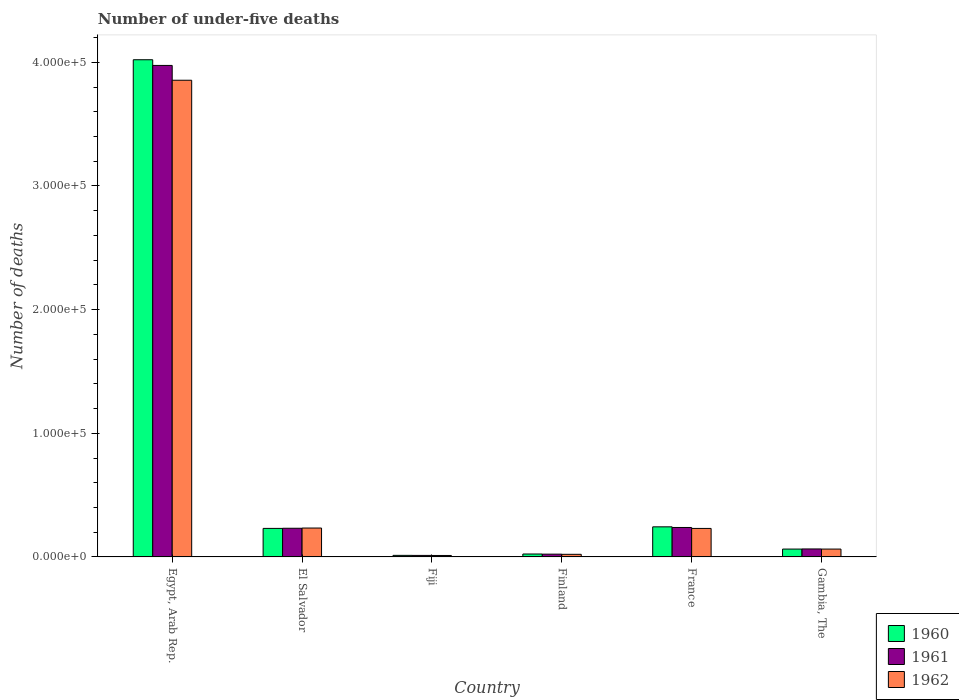How many different coloured bars are there?
Provide a short and direct response. 3. How many groups of bars are there?
Keep it short and to the point. 6. Are the number of bars per tick equal to the number of legend labels?
Your answer should be very brief. Yes. Are the number of bars on each tick of the X-axis equal?
Offer a very short reply. Yes. How many bars are there on the 4th tick from the left?
Give a very brief answer. 3. What is the label of the 2nd group of bars from the left?
Keep it short and to the point. El Salvador. What is the number of under-five deaths in 1961 in Gambia, The?
Ensure brevity in your answer.  6452. Across all countries, what is the maximum number of under-five deaths in 1962?
Your response must be concise. 3.86e+05. Across all countries, what is the minimum number of under-five deaths in 1962?
Ensure brevity in your answer.  1176. In which country was the number of under-five deaths in 1961 maximum?
Give a very brief answer. Egypt, Arab Rep. In which country was the number of under-five deaths in 1961 minimum?
Provide a short and direct response. Fiji. What is the total number of under-five deaths in 1961 in the graph?
Your answer should be very brief. 4.54e+05. What is the difference between the number of under-five deaths in 1961 in Egypt, Arab Rep. and that in El Salvador?
Make the answer very short. 3.74e+05. What is the difference between the number of under-five deaths in 1960 in Gambia, The and the number of under-five deaths in 1961 in France?
Ensure brevity in your answer.  -1.75e+04. What is the average number of under-five deaths in 1961 per country?
Ensure brevity in your answer.  7.57e+04. What is the difference between the number of under-five deaths of/in 1962 and number of under-five deaths of/in 1960 in Finland?
Provide a succinct answer. -257. In how many countries, is the number of under-five deaths in 1962 greater than 140000?
Give a very brief answer. 1. What is the ratio of the number of under-five deaths in 1960 in Egypt, Arab Rep. to that in Fiji?
Your answer should be very brief. 318.38. What is the difference between the highest and the second highest number of under-five deaths in 1961?
Make the answer very short. 3.74e+05. What is the difference between the highest and the lowest number of under-five deaths in 1961?
Offer a terse response. 3.96e+05. In how many countries, is the number of under-five deaths in 1960 greater than the average number of under-five deaths in 1960 taken over all countries?
Keep it short and to the point. 1. Is the sum of the number of under-five deaths in 1962 in Egypt, Arab Rep. and France greater than the maximum number of under-five deaths in 1960 across all countries?
Provide a succinct answer. Yes. What does the 2nd bar from the left in Egypt, Arab Rep. represents?
Your answer should be compact. 1961. How many bars are there?
Ensure brevity in your answer.  18. Are the values on the major ticks of Y-axis written in scientific E-notation?
Make the answer very short. Yes. What is the title of the graph?
Ensure brevity in your answer.  Number of under-five deaths. Does "1984" appear as one of the legend labels in the graph?
Keep it short and to the point. No. What is the label or title of the Y-axis?
Keep it short and to the point. Number of deaths. What is the Number of deaths of 1960 in Egypt, Arab Rep.?
Ensure brevity in your answer.  4.02e+05. What is the Number of deaths in 1961 in Egypt, Arab Rep.?
Offer a terse response. 3.98e+05. What is the Number of deaths of 1962 in Egypt, Arab Rep.?
Your response must be concise. 3.86e+05. What is the Number of deaths in 1960 in El Salvador?
Make the answer very short. 2.31e+04. What is the Number of deaths in 1961 in El Salvador?
Keep it short and to the point. 2.32e+04. What is the Number of deaths of 1962 in El Salvador?
Offer a very short reply. 2.34e+04. What is the Number of deaths of 1960 in Fiji?
Offer a terse response. 1263. What is the Number of deaths of 1961 in Fiji?
Your answer should be very brief. 1222. What is the Number of deaths of 1962 in Fiji?
Provide a short and direct response. 1176. What is the Number of deaths of 1960 in Finland?
Offer a very short reply. 2363. What is the Number of deaths in 1961 in Finland?
Ensure brevity in your answer.  2251. What is the Number of deaths in 1962 in Finland?
Your response must be concise. 2106. What is the Number of deaths of 1960 in France?
Offer a very short reply. 2.43e+04. What is the Number of deaths of 1961 in France?
Your answer should be very brief. 2.38e+04. What is the Number of deaths in 1962 in France?
Offer a very short reply. 2.30e+04. What is the Number of deaths in 1960 in Gambia, The?
Provide a succinct answer. 6353. What is the Number of deaths of 1961 in Gambia, The?
Provide a short and direct response. 6452. What is the Number of deaths in 1962 in Gambia, The?
Ensure brevity in your answer.  6361. Across all countries, what is the maximum Number of deaths of 1960?
Make the answer very short. 4.02e+05. Across all countries, what is the maximum Number of deaths in 1961?
Keep it short and to the point. 3.98e+05. Across all countries, what is the maximum Number of deaths in 1962?
Keep it short and to the point. 3.86e+05. Across all countries, what is the minimum Number of deaths of 1960?
Offer a very short reply. 1263. Across all countries, what is the minimum Number of deaths of 1961?
Make the answer very short. 1222. Across all countries, what is the minimum Number of deaths in 1962?
Keep it short and to the point. 1176. What is the total Number of deaths in 1960 in the graph?
Make the answer very short. 4.60e+05. What is the total Number of deaths in 1961 in the graph?
Ensure brevity in your answer.  4.54e+05. What is the total Number of deaths in 1962 in the graph?
Provide a short and direct response. 4.42e+05. What is the difference between the Number of deaths of 1960 in Egypt, Arab Rep. and that in El Salvador?
Offer a very short reply. 3.79e+05. What is the difference between the Number of deaths of 1961 in Egypt, Arab Rep. and that in El Salvador?
Offer a very short reply. 3.74e+05. What is the difference between the Number of deaths in 1962 in Egypt, Arab Rep. and that in El Salvador?
Keep it short and to the point. 3.62e+05. What is the difference between the Number of deaths in 1960 in Egypt, Arab Rep. and that in Fiji?
Provide a succinct answer. 4.01e+05. What is the difference between the Number of deaths in 1961 in Egypt, Arab Rep. and that in Fiji?
Provide a short and direct response. 3.96e+05. What is the difference between the Number of deaths in 1962 in Egypt, Arab Rep. and that in Fiji?
Your answer should be compact. 3.84e+05. What is the difference between the Number of deaths in 1960 in Egypt, Arab Rep. and that in Finland?
Offer a very short reply. 4.00e+05. What is the difference between the Number of deaths in 1961 in Egypt, Arab Rep. and that in Finland?
Offer a very short reply. 3.95e+05. What is the difference between the Number of deaths of 1962 in Egypt, Arab Rep. and that in Finland?
Your response must be concise. 3.83e+05. What is the difference between the Number of deaths in 1960 in Egypt, Arab Rep. and that in France?
Offer a very short reply. 3.78e+05. What is the difference between the Number of deaths in 1961 in Egypt, Arab Rep. and that in France?
Keep it short and to the point. 3.74e+05. What is the difference between the Number of deaths of 1962 in Egypt, Arab Rep. and that in France?
Provide a succinct answer. 3.62e+05. What is the difference between the Number of deaths in 1960 in Egypt, Arab Rep. and that in Gambia, The?
Keep it short and to the point. 3.96e+05. What is the difference between the Number of deaths of 1961 in Egypt, Arab Rep. and that in Gambia, The?
Your answer should be very brief. 3.91e+05. What is the difference between the Number of deaths in 1962 in Egypt, Arab Rep. and that in Gambia, The?
Provide a short and direct response. 3.79e+05. What is the difference between the Number of deaths in 1960 in El Salvador and that in Fiji?
Ensure brevity in your answer.  2.18e+04. What is the difference between the Number of deaths in 1961 in El Salvador and that in Fiji?
Your response must be concise. 2.20e+04. What is the difference between the Number of deaths of 1962 in El Salvador and that in Fiji?
Give a very brief answer. 2.22e+04. What is the difference between the Number of deaths of 1960 in El Salvador and that in Finland?
Your response must be concise. 2.07e+04. What is the difference between the Number of deaths of 1961 in El Salvador and that in Finland?
Keep it short and to the point. 2.09e+04. What is the difference between the Number of deaths in 1962 in El Salvador and that in Finland?
Provide a succinct answer. 2.13e+04. What is the difference between the Number of deaths in 1960 in El Salvador and that in France?
Provide a short and direct response. -1262. What is the difference between the Number of deaths of 1961 in El Salvador and that in France?
Give a very brief answer. -627. What is the difference between the Number of deaths of 1962 in El Salvador and that in France?
Give a very brief answer. 323. What is the difference between the Number of deaths in 1960 in El Salvador and that in Gambia, The?
Provide a short and direct response. 1.67e+04. What is the difference between the Number of deaths in 1961 in El Salvador and that in Gambia, The?
Offer a very short reply. 1.67e+04. What is the difference between the Number of deaths in 1962 in El Salvador and that in Gambia, The?
Your answer should be compact. 1.70e+04. What is the difference between the Number of deaths of 1960 in Fiji and that in Finland?
Make the answer very short. -1100. What is the difference between the Number of deaths in 1961 in Fiji and that in Finland?
Offer a very short reply. -1029. What is the difference between the Number of deaths of 1962 in Fiji and that in Finland?
Give a very brief answer. -930. What is the difference between the Number of deaths in 1960 in Fiji and that in France?
Offer a terse response. -2.31e+04. What is the difference between the Number of deaths in 1961 in Fiji and that in France?
Give a very brief answer. -2.26e+04. What is the difference between the Number of deaths in 1962 in Fiji and that in France?
Ensure brevity in your answer.  -2.19e+04. What is the difference between the Number of deaths in 1960 in Fiji and that in Gambia, The?
Offer a very short reply. -5090. What is the difference between the Number of deaths in 1961 in Fiji and that in Gambia, The?
Offer a terse response. -5230. What is the difference between the Number of deaths of 1962 in Fiji and that in Gambia, The?
Offer a very short reply. -5185. What is the difference between the Number of deaths of 1960 in Finland and that in France?
Your response must be concise. -2.20e+04. What is the difference between the Number of deaths of 1961 in Finland and that in France?
Provide a succinct answer. -2.16e+04. What is the difference between the Number of deaths in 1962 in Finland and that in France?
Your response must be concise. -2.09e+04. What is the difference between the Number of deaths in 1960 in Finland and that in Gambia, The?
Offer a terse response. -3990. What is the difference between the Number of deaths of 1961 in Finland and that in Gambia, The?
Offer a terse response. -4201. What is the difference between the Number of deaths in 1962 in Finland and that in Gambia, The?
Offer a terse response. -4255. What is the difference between the Number of deaths in 1960 in France and that in Gambia, The?
Your answer should be compact. 1.80e+04. What is the difference between the Number of deaths of 1961 in France and that in Gambia, The?
Provide a short and direct response. 1.74e+04. What is the difference between the Number of deaths of 1962 in France and that in Gambia, The?
Give a very brief answer. 1.67e+04. What is the difference between the Number of deaths in 1960 in Egypt, Arab Rep. and the Number of deaths in 1961 in El Salvador?
Give a very brief answer. 3.79e+05. What is the difference between the Number of deaths of 1960 in Egypt, Arab Rep. and the Number of deaths of 1962 in El Salvador?
Your answer should be compact. 3.79e+05. What is the difference between the Number of deaths in 1961 in Egypt, Arab Rep. and the Number of deaths in 1962 in El Salvador?
Provide a short and direct response. 3.74e+05. What is the difference between the Number of deaths of 1960 in Egypt, Arab Rep. and the Number of deaths of 1961 in Fiji?
Your answer should be very brief. 4.01e+05. What is the difference between the Number of deaths of 1960 in Egypt, Arab Rep. and the Number of deaths of 1962 in Fiji?
Your response must be concise. 4.01e+05. What is the difference between the Number of deaths in 1961 in Egypt, Arab Rep. and the Number of deaths in 1962 in Fiji?
Keep it short and to the point. 3.96e+05. What is the difference between the Number of deaths in 1960 in Egypt, Arab Rep. and the Number of deaths in 1961 in Finland?
Offer a terse response. 4.00e+05. What is the difference between the Number of deaths of 1960 in Egypt, Arab Rep. and the Number of deaths of 1962 in Finland?
Provide a succinct answer. 4.00e+05. What is the difference between the Number of deaths of 1961 in Egypt, Arab Rep. and the Number of deaths of 1962 in Finland?
Provide a succinct answer. 3.95e+05. What is the difference between the Number of deaths in 1960 in Egypt, Arab Rep. and the Number of deaths in 1961 in France?
Give a very brief answer. 3.78e+05. What is the difference between the Number of deaths of 1960 in Egypt, Arab Rep. and the Number of deaths of 1962 in France?
Ensure brevity in your answer.  3.79e+05. What is the difference between the Number of deaths in 1961 in Egypt, Arab Rep. and the Number of deaths in 1962 in France?
Your answer should be compact. 3.74e+05. What is the difference between the Number of deaths in 1960 in Egypt, Arab Rep. and the Number of deaths in 1961 in Gambia, The?
Provide a succinct answer. 3.96e+05. What is the difference between the Number of deaths in 1960 in Egypt, Arab Rep. and the Number of deaths in 1962 in Gambia, The?
Your answer should be very brief. 3.96e+05. What is the difference between the Number of deaths of 1961 in Egypt, Arab Rep. and the Number of deaths of 1962 in Gambia, The?
Provide a short and direct response. 3.91e+05. What is the difference between the Number of deaths in 1960 in El Salvador and the Number of deaths in 1961 in Fiji?
Provide a short and direct response. 2.19e+04. What is the difference between the Number of deaths in 1960 in El Salvador and the Number of deaths in 1962 in Fiji?
Give a very brief answer. 2.19e+04. What is the difference between the Number of deaths of 1961 in El Salvador and the Number of deaths of 1962 in Fiji?
Offer a very short reply. 2.20e+04. What is the difference between the Number of deaths in 1960 in El Salvador and the Number of deaths in 1961 in Finland?
Provide a succinct answer. 2.08e+04. What is the difference between the Number of deaths of 1960 in El Salvador and the Number of deaths of 1962 in Finland?
Make the answer very short. 2.10e+04. What is the difference between the Number of deaths in 1961 in El Salvador and the Number of deaths in 1962 in Finland?
Your answer should be compact. 2.11e+04. What is the difference between the Number of deaths of 1960 in El Salvador and the Number of deaths of 1961 in France?
Provide a succinct answer. -745. What is the difference between the Number of deaths in 1961 in El Salvador and the Number of deaths in 1962 in France?
Make the answer very short. 148. What is the difference between the Number of deaths of 1960 in El Salvador and the Number of deaths of 1961 in Gambia, The?
Offer a very short reply. 1.66e+04. What is the difference between the Number of deaths in 1960 in El Salvador and the Number of deaths in 1962 in Gambia, The?
Ensure brevity in your answer.  1.67e+04. What is the difference between the Number of deaths in 1961 in El Salvador and the Number of deaths in 1962 in Gambia, The?
Provide a succinct answer. 1.68e+04. What is the difference between the Number of deaths of 1960 in Fiji and the Number of deaths of 1961 in Finland?
Make the answer very short. -988. What is the difference between the Number of deaths in 1960 in Fiji and the Number of deaths in 1962 in Finland?
Provide a succinct answer. -843. What is the difference between the Number of deaths of 1961 in Fiji and the Number of deaths of 1962 in Finland?
Ensure brevity in your answer.  -884. What is the difference between the Number of deaths in 1960 in Fiji and the Number of deaths in 1961 in France?
Give a very brief answer. -2.26e+04. What is the difference between the Number of deaths in 1960 in Fiji and the Number of deaths in 1962 in France?
Provide a short and direct response. -2.18e+04. What is the difference between the Number of deaths of 1961 in Fiji and the Number of deaths of 1962 in France?
Give a very brief answer. -2.18e+04. What is the difference between the Number of deaths of 1960 in Fiji and the Number of deaths of 1961 in Gambia, The?
Your answer should be compact. -5189. What is the difference between the Number of deaths of 1960 in Fiji and the Number of deaths of 1962 in Gambia, The?
Your answer should be very brief. -5098. What is the difference between the Number of deaths of 1961 in Fiji and the Number of deaths of 1962 in Gambia, The?
Provide a short and direct response. -5139. What is the difference between the Number of deaths in 1960 in Finland and the Number of deaths in 1961 in France?
Your response must be concise. -2.15e+04. What is the difference between the Number of deaths of 1960 in Finland and the Number of deaths of 1962 in France?
Offer a very short reply. -2.07e+04. What is the difference between the Number of deaths of 1961 in Finland and the Number of deaths of 1962 in France?
Your response must be concise. -2.08e+04. What is the difference between the Number of deaths in 1960 in Finland and the Number of deaths in 1961 in Gambia, The?
Offer a terse response. -4089. What is the difference between the Number of deaths in 1960 in Finland and the Number of deaths in 1962 in Gambia, The?
Offer a very short reply. -3998. What is the difference between the Number of deaths of 1961 in Finland and the Number of deaths of 1962 in Gambia, The?
Offer a very short reply. -4110. What is the difference between the Number of deaths in 1960 in France and the Number of deaths in 1961 in Gambia, The?
Your answer should be compact. 1.79e+04. What is the difference between the Number of deaths in 1960 in France and the Number of deaths in 1962 in Gambia, The?
Provide a succinct answer. 1.80e+04. What is the difference between the Number of deaths in 1961 in France and the Number of deaths in 1962 in Gambia, The?
Your response must be concise. 1.75e+04. What is the average Number of deaths of 1960 per country?
Keep it short and to the point. 7.66e+04. What is the average Number of deaths of 1961 per country?
Provide a short and direct response. 7.57e+04. What is the average Number of deaths in 1962 per country?
Your response must be concise. 7.36e+04. What is the difference between the Number of deaths of 1960 and Number of deaths of 1961 in Egypt, Arab Rep.?
Your answer should be compact. 4607. What is the difference between the Number of deaths in 1960 and Number of deaths in 1962 in Egypt, Arab Rep.?
Offer a very short reply. 1.66e+04. What is the difference between the Number of deaths in 1961 and Number of deaths in 1962 in Egypt, Arab Rep.?
Give a very brief answer. 1.20e+04. What is the difference between the Number of deaths of 1960 and Number of deaths of 1961 in El Salvador?
Keep it short and to the point. -118. What is the difference between the Number of deaths of 1960 and Number of deaths of 1962 in El Salvador?
Keep it short and to the point. -293. What is the difference between the Number of deaths in 1961 and Number of deaths in 1962 in El Salvador?
Your response must be concise. -175. What is the difference between the Number of deaths of 1960 and Number of deaths of 1962 in Fiji?
Offer a very short reply. 87. What is the difference between the Number of deaths of 1961 and Number of deaths of 1962 in Fiji?
Offer a very short reply. 46. What is the difference between the Number of deaths in 1960 and Number of deaths in 1961 in Finland?
Offer a terse response. 112. What is the difference between the Number of deaths in 1960 and Number of deaths in 1962 in Finland?
Make the answer very short. 257. What is the difference between the Number of deaths in 1961 and Number of deaths in 1962 in Finland?
Provide a succinct answer. 145. What is the difference between the Number of deaths of 1960 and Number of deaths of 1961 in France?
Offer a very short reply. 517. What is the difference between the Number of deaths of 1960 and Number of deaths of 1962 in France?
Offer a very short reply. 1292. What is the difference between the Number of deaths in 1961 and Number of deaths in 1962 in France?
Your answer should be compact. 775. What is the difference between the Number of deaths in 1960 and Number of deaths in 1961 in Gambia, The?
Provide a short and direct response. -99. What is the difference between the Number of deaths of 1961 and Number of deaths of 1962 in Gambia, The?
Provide a short and direct response. 91. What is the ratio of the Number of deaths in 1960 in Egypt, Arab Rep. to that in El Salvador?
Your answer should be very brief. 17.43. What is the ratio of the Number of deaths in 1961 in Egypt, Arab Rep. to that in El Salvador?
Offer a very short reply. 17.14. What is the ratio of the Number of deaths of 1962 in Egypt, Arab Rep. to that in El Salvador?
Your response must be concise. 16.5. What is the ratio of the Number of deaths of 1960 in Egypt, Arab Rep. to that in Fiji?
Provide a short and direct response. 318.38. What is the ratio of the Number of deaths of 1961 in Egypt, Arab Rep. to that in Fiji?
Your answer should be compact. 325.29. What is the ratio of the Number of deaths of 1962 in Egypt, Arab Rep. to that in Fiji?
Offer a very short reply. 327.83. What is the ratio of the Number of deaths of 1960 in Egypt, Arab Rep. to that in Finland?
Your response must be concise. 170.17. What is the ratio of the Number of deaths in 1961 in Egypt, Arab Rep. to that in Finland?
Keep it short and to the point. 176.59. What is the ratio of the Number of deaths of 1962 in Egypt, Arab Rep. to that in Finland?
Ensure brevity in your answer.  183.06. What is the ratio of the Number of deaths of 1960 in Egypt, Arab Rep. to that in France?
Your response must be concise. 16.52. What is the ratio of the Number of deaths of 1961 in Egypt, Arab Rep. to that in France?
Offer a terse response. 16.69. What is the ratio of the Number of deaths of 1962 in Egypt, Arab Rep. to that in France?
Your response must be concise. 16.73. What is the ratio of the Number of deaths in 1960 in Egypt, Arab Rep. to that in Gambia, The?
Make the answer very short. 63.3. What is the ratio of the Number of deaths in 1961 in Egypt, Arab Rep. to that in Gambia, The?
Provide a succinct answer. 61.61. What is the ratio of the Number of deaths in 1962 in Egypt, Arab Rep. to that in Gambia, The?
Offer a terse response. 60.61. What is the ratio of the Number of deaths of 1960 in El Salvador to that in Fiji?
Your answer should be very brief. 18.27. What is the ratio of the Number of deaths of 1961 in El Salvador to that in Fiji?
Offer a very short reply. 18.98. What is the ratio of the Number of deaths in 1962 in El Salvador to that in Fiji?
Your answer should be compact. 19.87. What is the ratio of the Number of deaths of 1960 in El Salvador to that in Finland?
Ensure brevity in your answer.  9.76. What is the ratio of the Number of deaths in 1961 in El Salvador to that in Finland?
Your response must be concise. 10.3. What is the ratio of the Number of deaths in 1962 in El Salvador to that in Finland?
Offer a very short reply. 11.1. What is the ratio of the Number of deaths in 1960 in El Salvador to that in France?
Ensure brevity in your answer.  0.95. What is the ratio of the Number of deaths of 1961 in El Salvador to that in France?
Your answer should be very brief. 0.97. What is the ratio of the Number of deaths in 1962 in El Salvador to that in France?
Your answer should be compact. 1.01. What is the ratio of the Number of deaths of 1960 in El Salvador to that in Gambia, The?
Provide a short and direct response. 3.63. What is the ratio of the Number of deaths in 1961 in El Salvador to that in Gambia, The?
Your answer should be very brief. 3.59. What is the ratio of the Number of deaths of 1962 in El Salvador to that in Gambia, The?
Your answer should be very brief. 3.67. What is the ratio of the Number of deaths in 1960 in Fiji to that in Finland?
Offer a very short reply. 0.53. What is the ratio of the Number of deaths in 1961 in Fiji to that in Finland?
Ensure brevity in your answer.  0.54. What is the ratio of the Number of deaths of 1962 in Fiji to that in Finland?
Give a very brief answer. 0.56. What is the ratio of the Number of deaths in 1960 in Fiji to that in France?
Provide a short and direct response. 0.05. What is the ratio of the Number of deaths of 1961 in Fiji to that in France?
Provide a short and direct response. 0.05. What is the ratio of the Number of deaths in 1962 in Fiji to that in France?
Give a very brief answer. 0.05. What is the ratio of the Number of deaths of 1960 in Fiji to that in Gambia, The?
Your answer should be compact. 0.2. What is the ratio of the Number of deaths in 1961 in Fiji to that in Gambia, The?
Offer a terse response. 0.19. What is the ratio of the Number of deaths in 1962 in Fiji to that in Gambia, The?
Make the answer very short. 0.18. What is the ratio of the Number of deaths of 1960 in Finland to that in France?
Provide a succinct answer. 0.1. What is the ratio of the Number of deaths in 1961 in Finland to that in France?
Your answer should be compact. 0.09. What is the ratio of the Number of deaths in 1962 in Finland to that in France?
Provide a short and direct response. 0.09. What is the ratio of the Number of deaths in 1960 in Finland to that in Gambia, The?
Provide a short and direct response. 0.37. What is the ratio of the Number of deaths in 1961 in Finland to that in Gambia, The?
Your response must be concise. 0.35. What is the ratio of the Number of deaths of 1962 in Finland to that in Gambia, The?
Your answer should be compact. 0.33. What is the ratio of the Number of deaths in 1960 in France to that in Gambia, The?
Provide a succinct answer. 3.83. What is the ratio of the Number of deaths in 1961 in France to that in Gambia, The?
Keep it short and to the point. 3.69. What is the ratio of the Number of deaths of 1962 in France to that in Gambia, The?
Provide a succinct answer. 3.62. What is the difference between the highest and the second highest Number of deaths of 1960?
Offer a very short reply. 3.78e+05. What is the difference between the highest and the second highest Number of deaths of 1961?
Your answer should be very brief. 3.74e+05. What is the difference between the highest and the second highest Number of deaths in 1962?
Ensure brevity in your answer.  3.62e+05. What is the difference between the highest and the lowest Number of deaths in 1960?
Offer a very short reply. 4.01e+05. What is the difference between the highest and the lowest Number of deaths in 1961?
Your response must be concise. 3.96e+05. What is the difference between the highest and the lowest Number of deaths of 1962?
Give a very brief answer. 3.84e+05. 